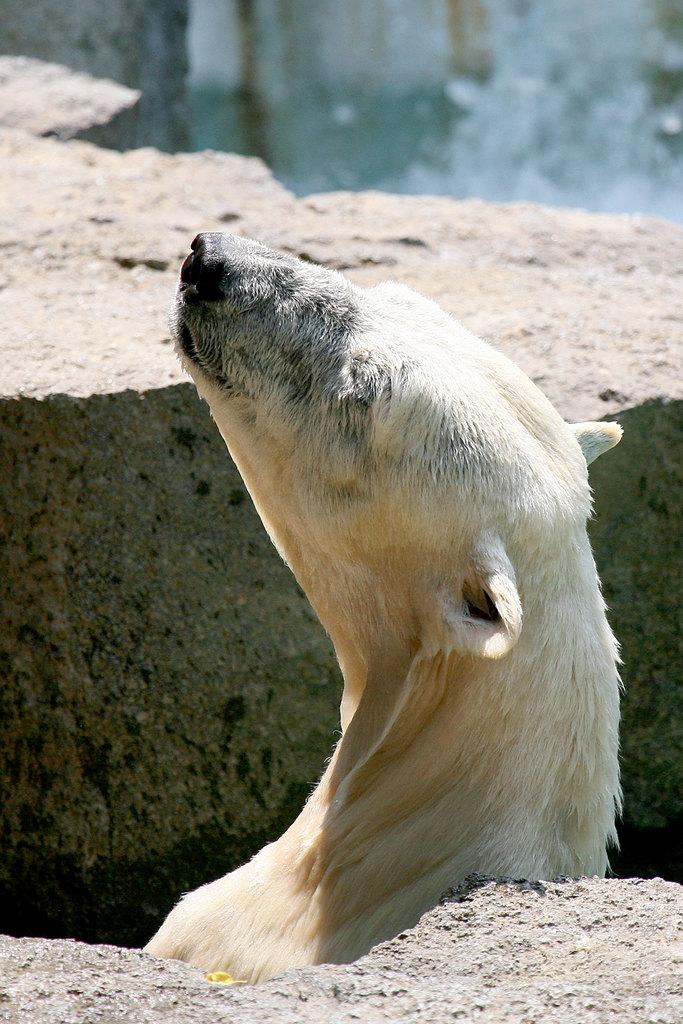What animal is the main subject of the image? There is a polar bear in the image. What type of terrain is visible in the image? There are rocks in the image. Can you describe the background of the image? The background of the image is blurry. How does the polar bear support the wilderness in the image? The polar bear does not support the wilderness in the image; it is simply an animal living in its natural habitat. What happens when the polar bear smashes the rocks in the image? There is no indication in the image that the polar bear is smashing the rocks, and therefore no such action can be observed. 